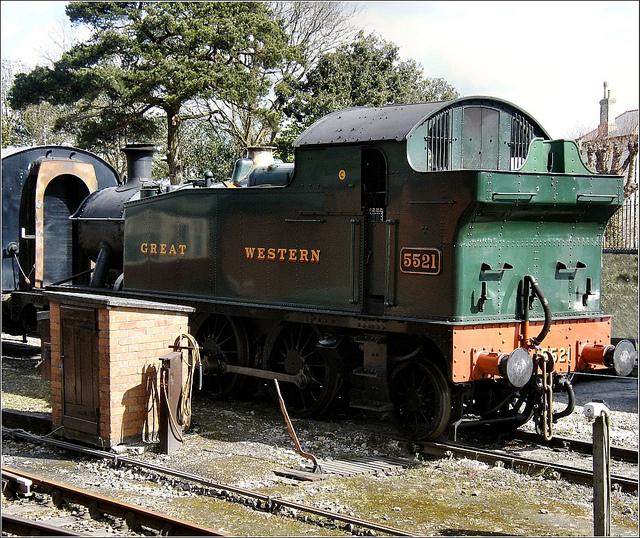What color is the train?
Quick response, please. Green. What is the name of this train?
Keep it brief. Great western. How many sets of tracks are visible?
Answer briefly. 2. 